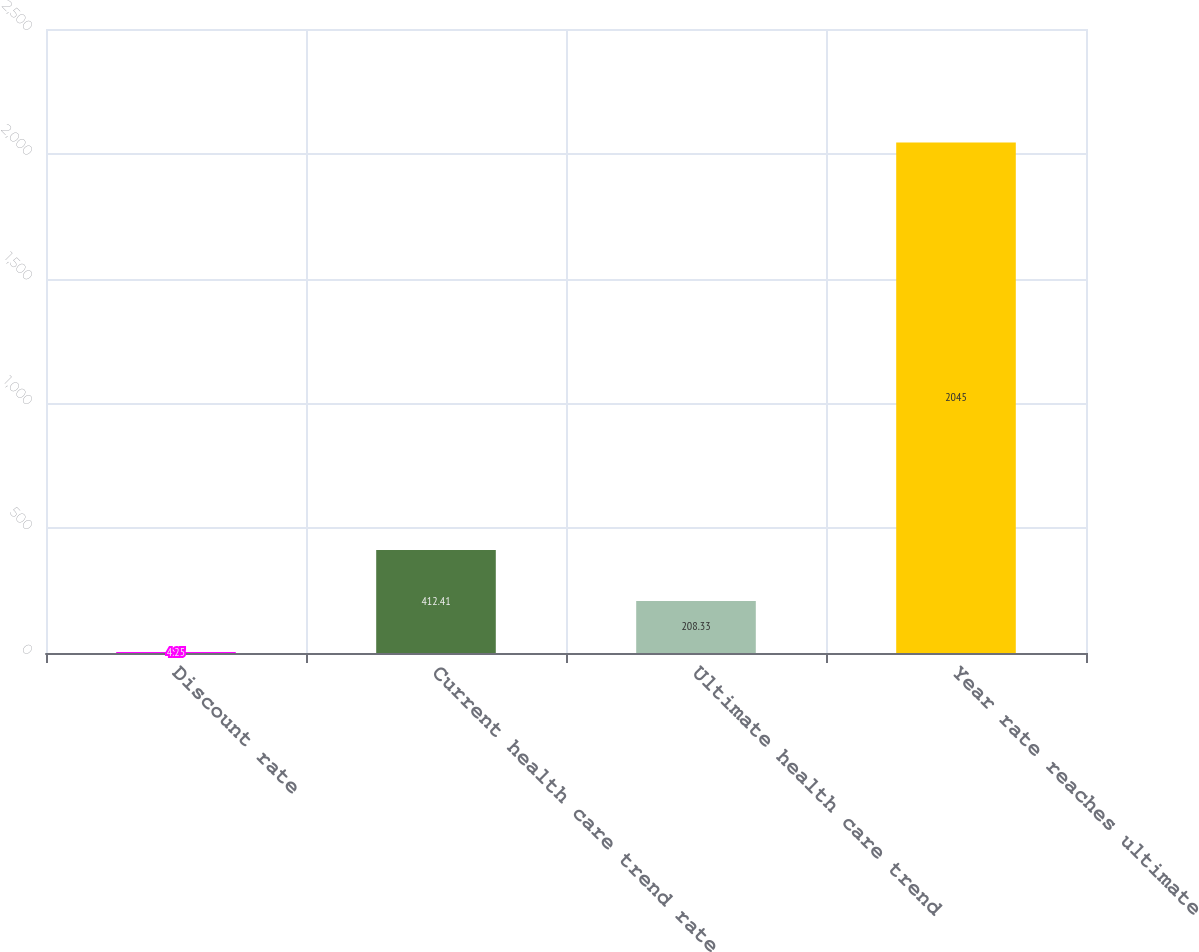<chart> <loc_0><loc_0><loc_500><loc_500><bar_chart><fcel>Discount rate<fcel>Current health care trend rate<fcel>Ultimate health care trend<fcel>Year rate reaches ultimate<nl><fcel>4.25<fcel>412.41<fcel>208.33<fcel>2045<nl></chart> 